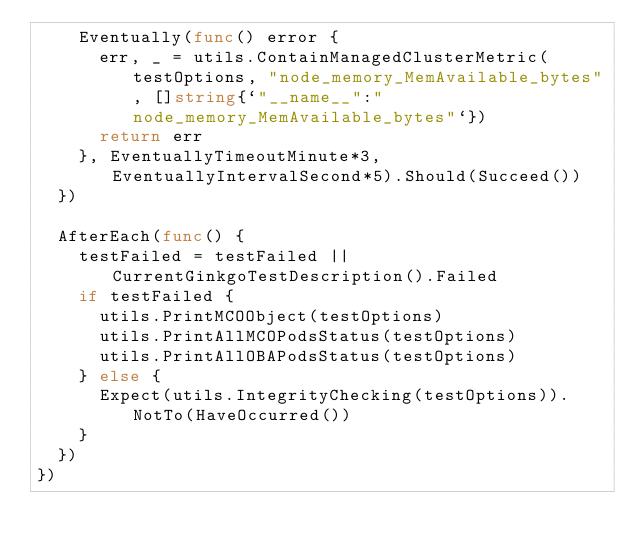<code> <loc_0><loc_0><loc_500><loc_500><_Go_>		Eventually(func() error {
			err, _ = utils.ContainManagedClusterMetric(testOptions, "node_memory_MemAvailable_bytes", []string{`"__name__":"node_memory_MemAvailable_bytes"`})
			return err
		}, EventuallyTimeoutMinute*3, EventuallyIntervalSecond*5).Should(Succeed())
	})

	AfterEach(func() {
		testFailed = testFailed || CurrentGinkgoTestDescription().Failed
		if testFailed {
			utils.PrintMCOObject(testOptions)
			utils.PrintAllMCOPodsStatus(testOptions)
			utils.PrintAllOBAPodsStatus(testOptions)
		} else {
			Expect(utils.IntegrityChecking(testOptions)).NotTo(HaveOccurred())
		}
	})
})
</code> 